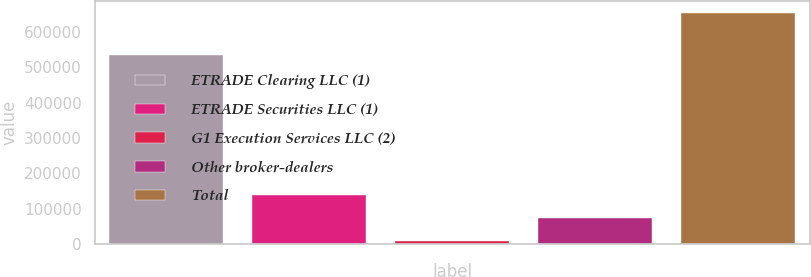Convert chart to OTSL. <chart><loc_0><loc_0><loc_500><loc_500><bar_chart><fcel>ETRADE Clearing LLC (1)<fcel>ETRADE Securities LLC (1)<fcel>G1 Execution Services LLC (2)<fcel>Other broker-dealers<fcel>Total<nl><fcel>535312<fcel>138477<fcel>9315<fcel>73896.1<fcel>655126<nl></chart> 